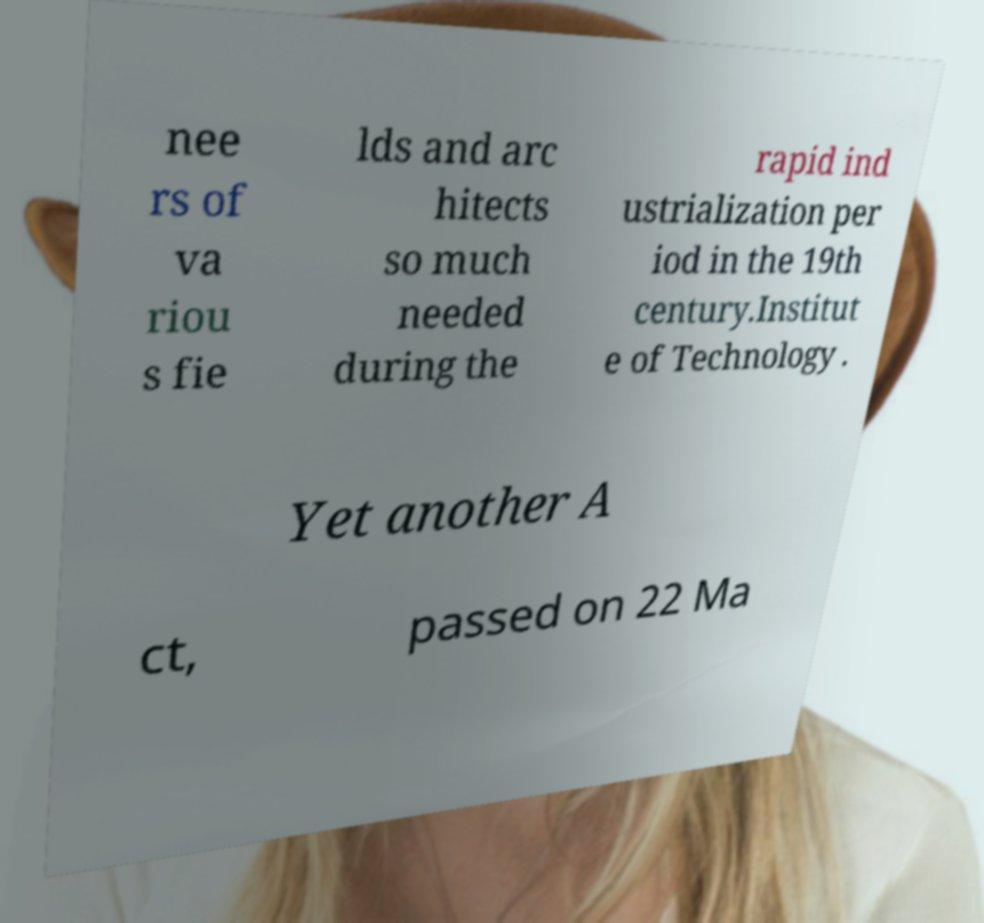There's text embedded in this image that I need extracted. Can you transcribe it verbatim? nee rs of va riou s fie lds and arc hitects so much needed during the rapid ind ustrialization per iod in the 19th century.Institut e of Technology . Yet another A ct, passed on 22 Ma 